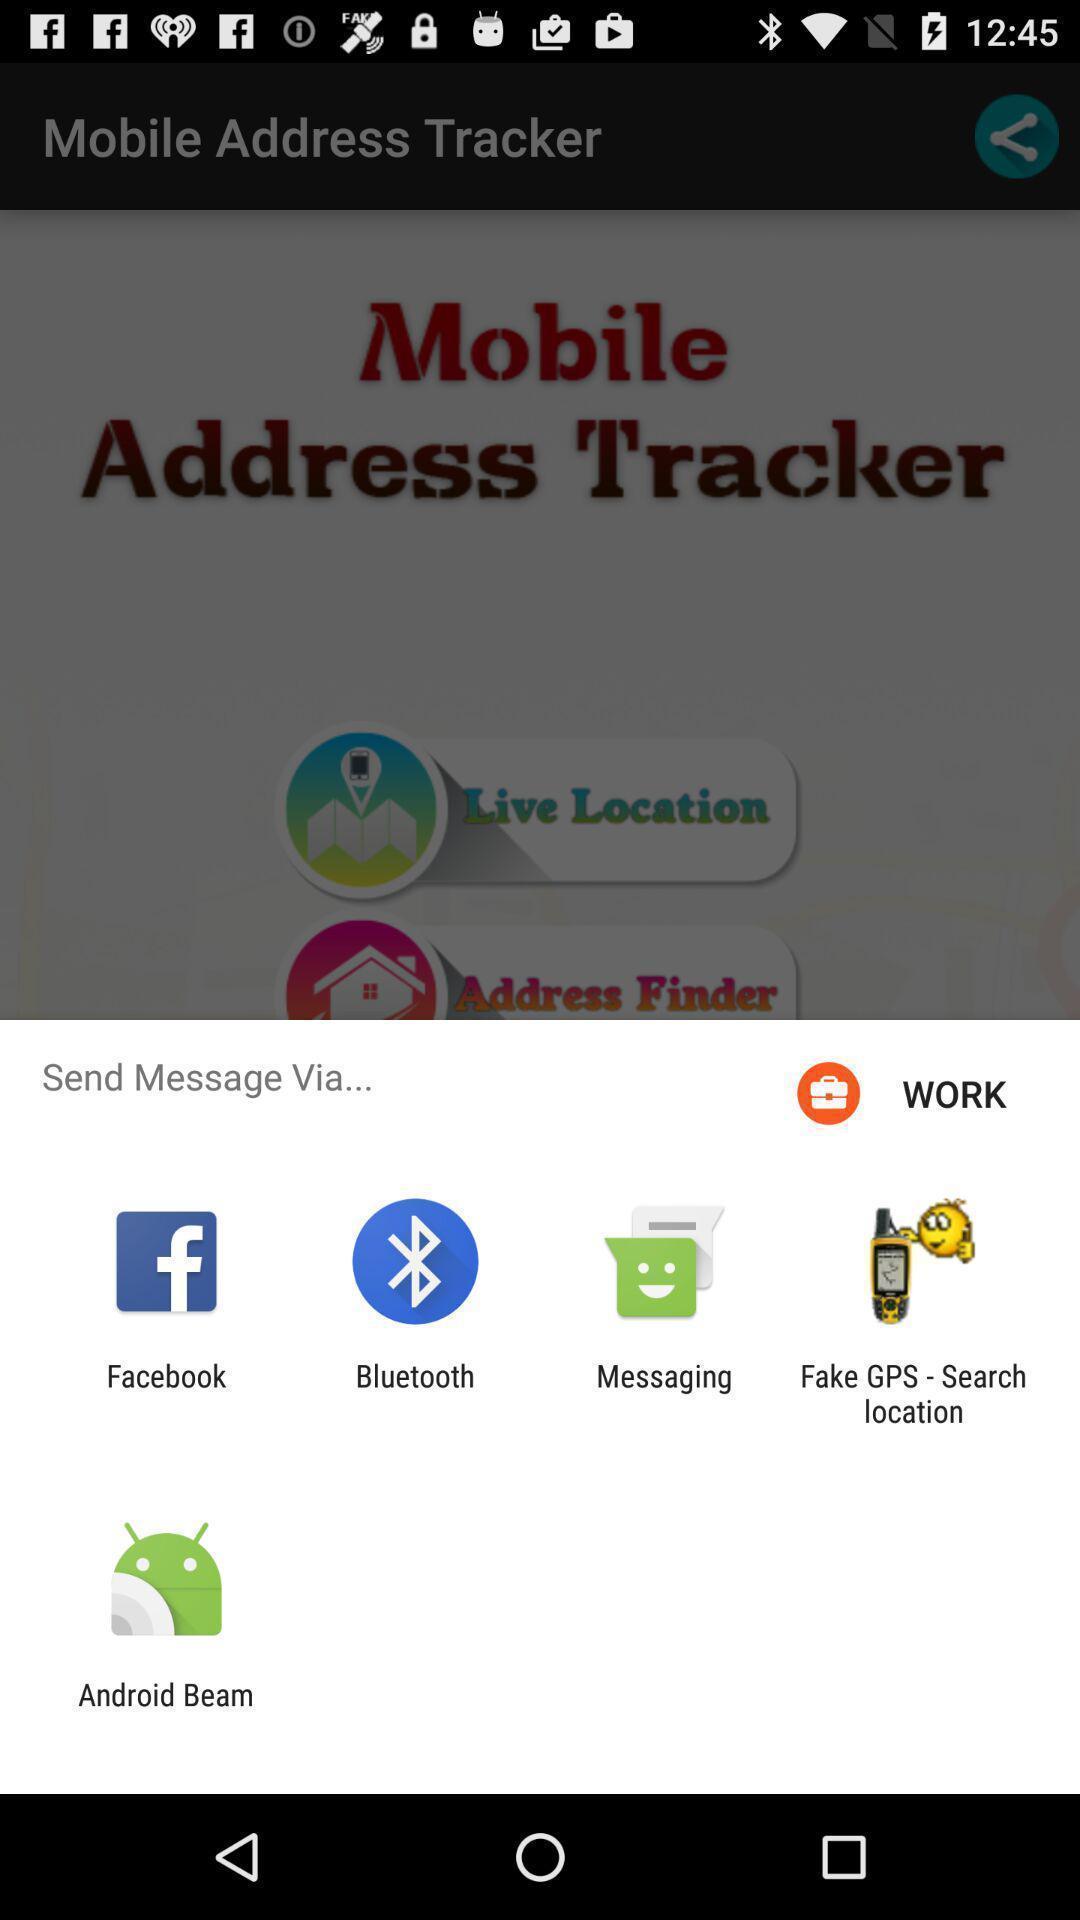Describe the visual elements of this screenshot. Push up page showing app preference to share. 